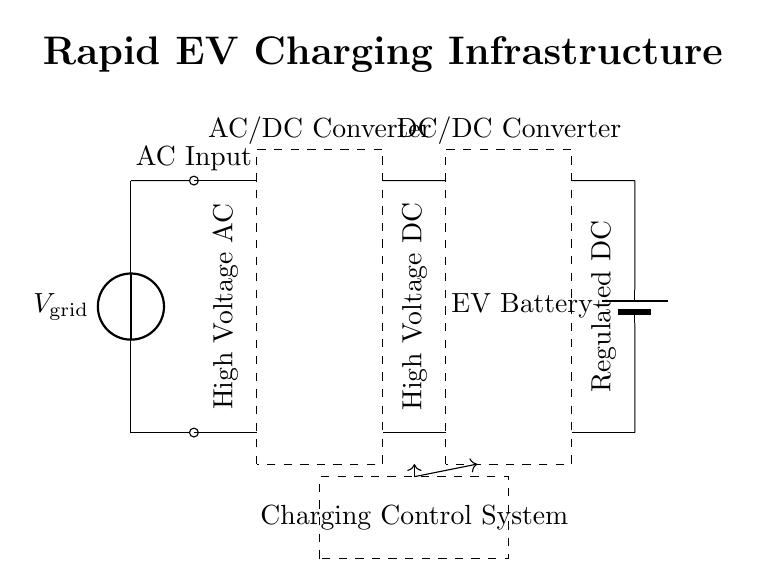What is the main source voltage in this circuit? The main source voltage is represented by the voltage source labeled as V_grid. It is the supply source that powers the entire charging infrastructure.
Answer: V_grid What component converts AC to DC? The component responsible for converting AC to DC is the AC/DC Converter, which is labeled in the circuit as a dashed rectangle. This converter ensures that the alternating current input is transformed into direct current suitable for charging.
Answer: AC/DC Converter What type of converter is used after the DC bus? The type of converter used after the DC bus is the DC/DC Converter. This component regulates the direct current, managing the voltage levels before delivering it to the charging port.
Answer: DC/DC Converter What is the purpose of the Charging Control System? The Charging Control System manages the flow of electricity through the circuit, ensuring that the vehicle's battery receives the correct voltage and current for optimal charging. It is located in a rectangular dashed area shown in the circuit.
Answer: Manage charging flow How many components are there in the circuit? The total number of components in the circuit includes one voltage source, one AC/DC converter, one DC bus, one DC/DC converter, one charging port, one battery, and one control system, which sums up to six distinct components.
Answer: Six What type of current does the Charging Port output? The Charging Port outputs regulated direct current, which is indicated by the labeling on the port connected to the electric vehicle battery, ensuring compatibility with the battery specifications.
Answer: Regulated direct current What is the primary load in this circuit? The primary load in the circuit is the EV Battery, which is the component being charged. It is crucial for energy storage in electric vehicles, and its representation as a battery indicates its role as the ultimate destination for the electrical energy flow.
Answer: EV Battery 